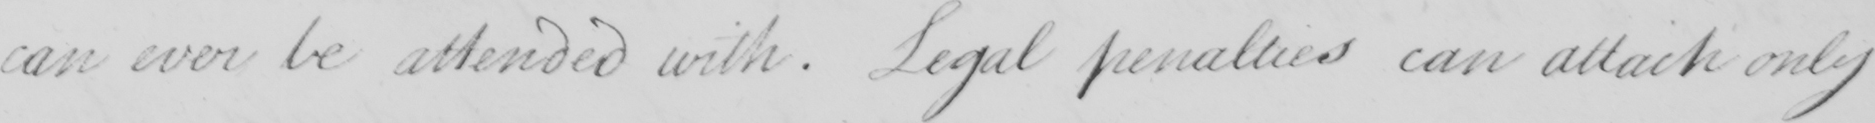What text is written in this handwritten line? can ever be attended with . Legal penalties can attack only 